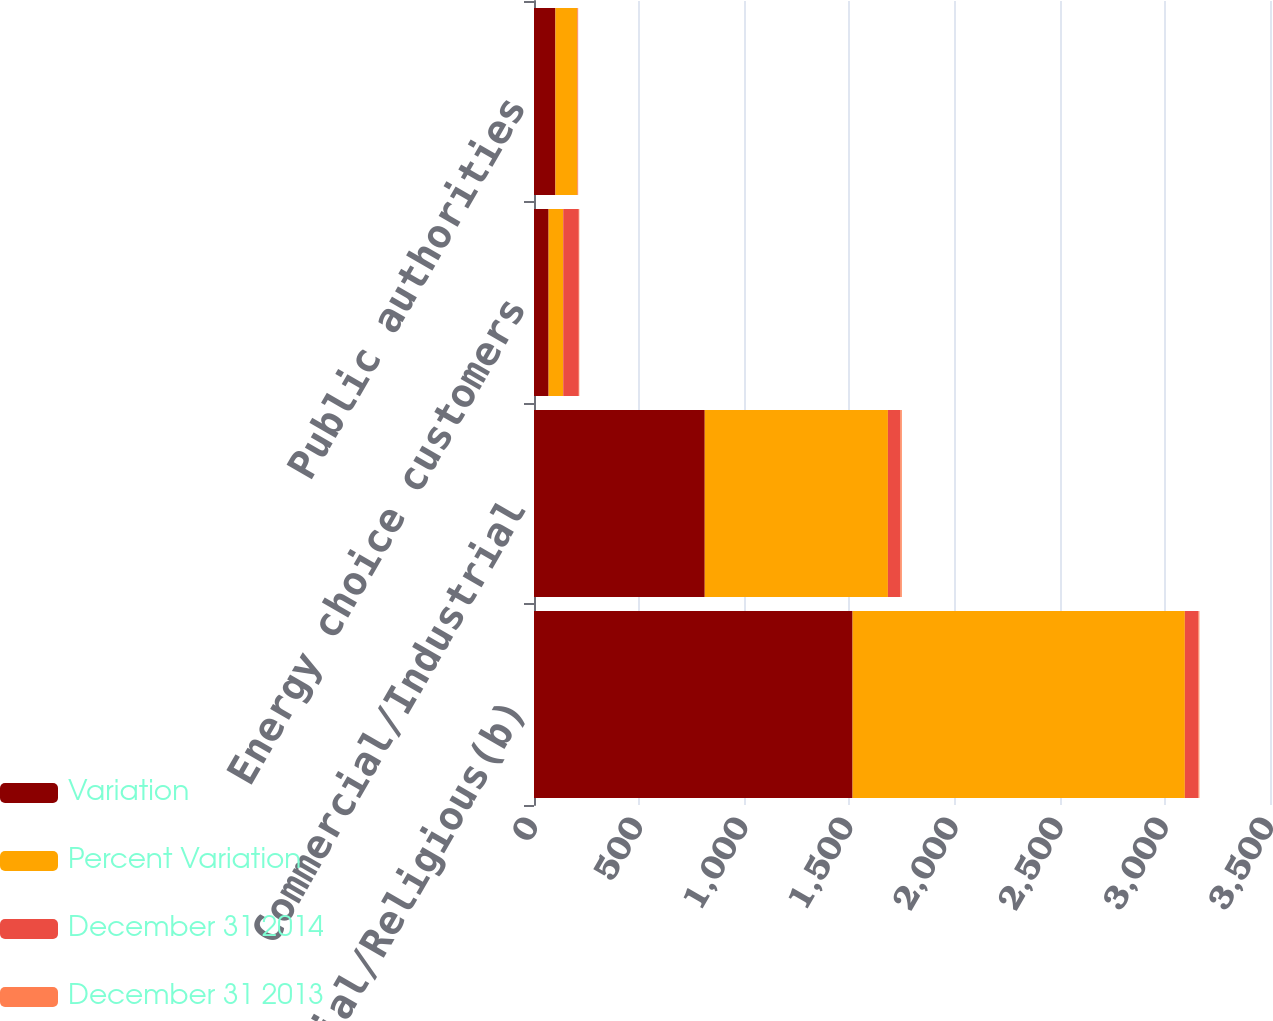Convert chart to OTSL. <chart><loc_0><loc_0><loc_500><loc_500><stacked_bar_chart><ecel><fcel>Residential/Religious(b)<fcel>Commercial/Industrial<fcel>Energy choice customers<fcel>Public authorities<nl><fcel>Variation<fcel>1515<fcel>812<fcel>69.5<fcel>102<nl><fcel>Percent Variation<fcel>1580<fcel>871<fcel>69.5<fcel>104<nl><fcel>December 31 2014<fcel>65<fcel>59<fcel>74<fcel>2<nl><fcel>December 31 2013<fcel>4.1<fcel>6.8<fcel>2.3<fcel>1.9<nl></chart> 